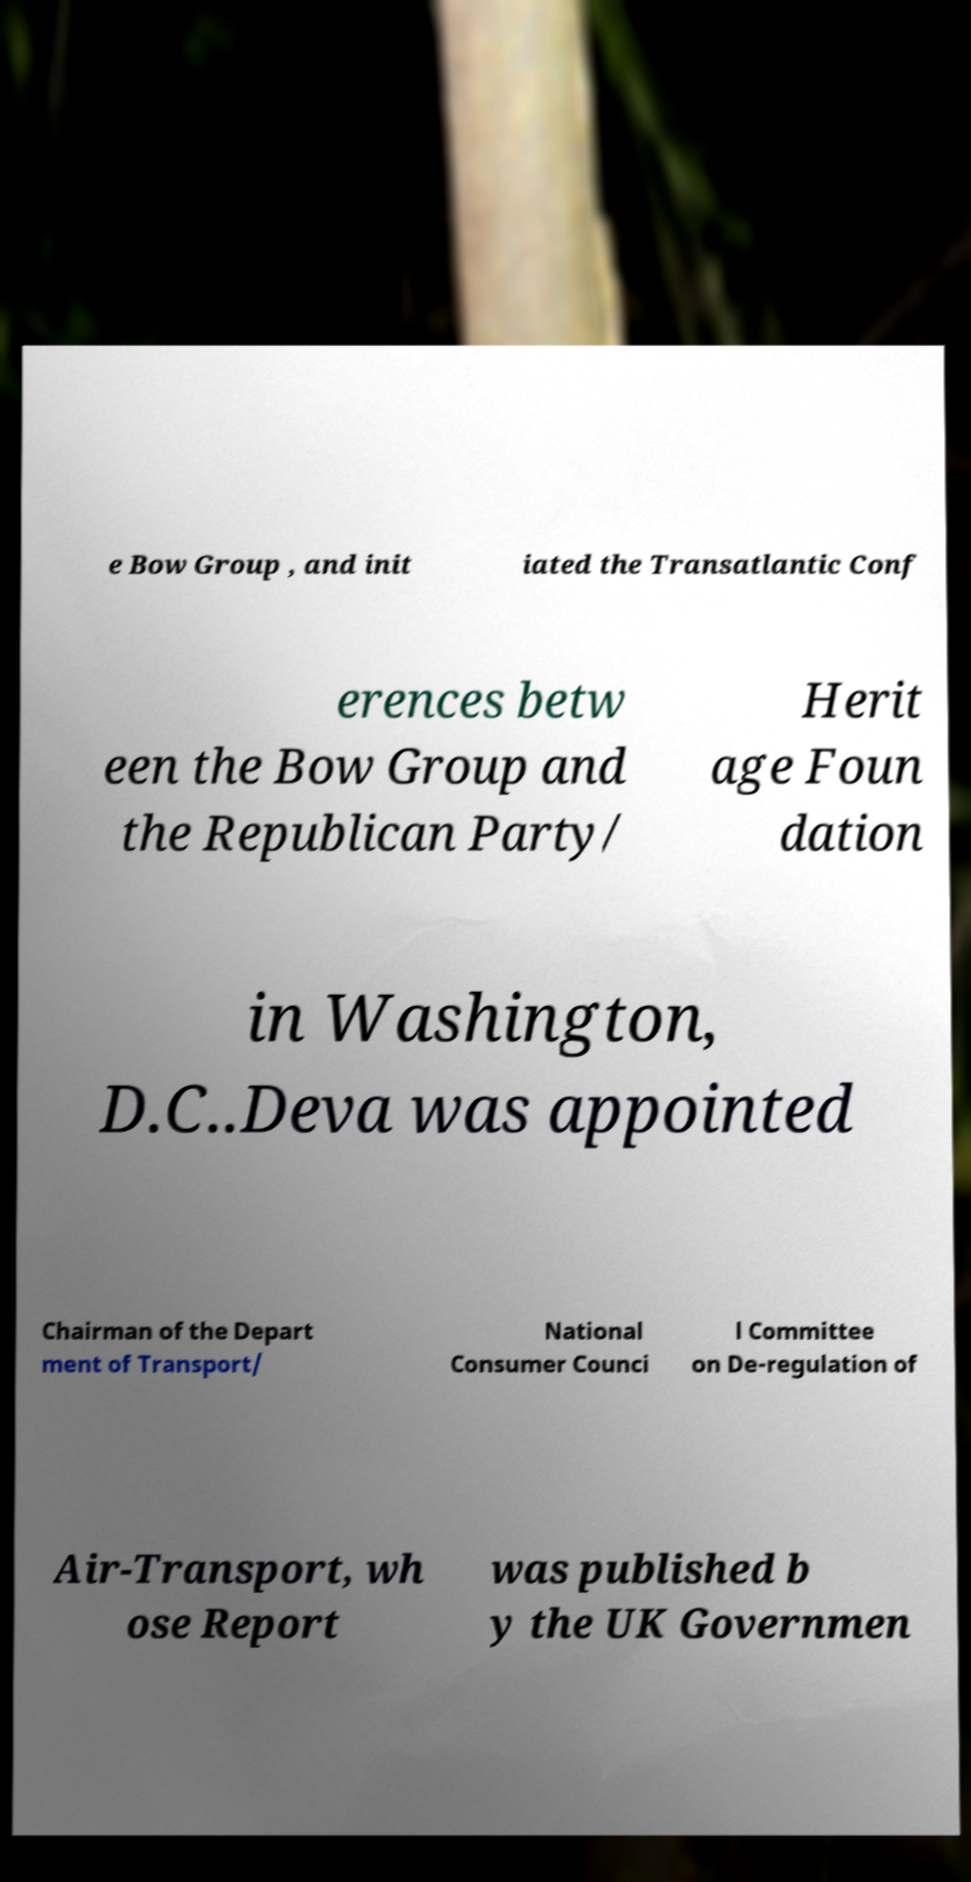Could you assist in decoding the text presented in this image and type it out clearly? e Bow Group , and init iated the Transatlantic Conf erences betw een the Bow Group and the Republican Party/ Herit age Foun dation in Washington, D.C..Deva was appointed Chairman of the Depart ment of Transport/ National Consumer Counci l Committee on De-regulation of Air-Transport, wh ose Report was published b y the UK Governmen 